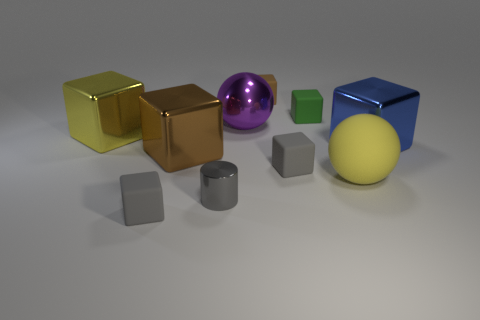Subtract 1 cubes. How many cubes are left? 6 Subtract all tiny brown rubber cubes. How many cubes are left? 6 Subtract all brown cubes. How many cubes are left? 5 Subtract all green cubes. Subtract all yellow cylinders. How many cubes are left? 6 Subtract all cubes. How many objects are left? 3 Add 1 large objects. How many large objects are left? 6 Add 1 tiny metal objects. How many tiny metal objects exist? 2 Subtract 0 green balls. How many objects are left? 10 Subtract all cyan cubes. Subtract all tiny brown matte objects. How many objects are left? 9 